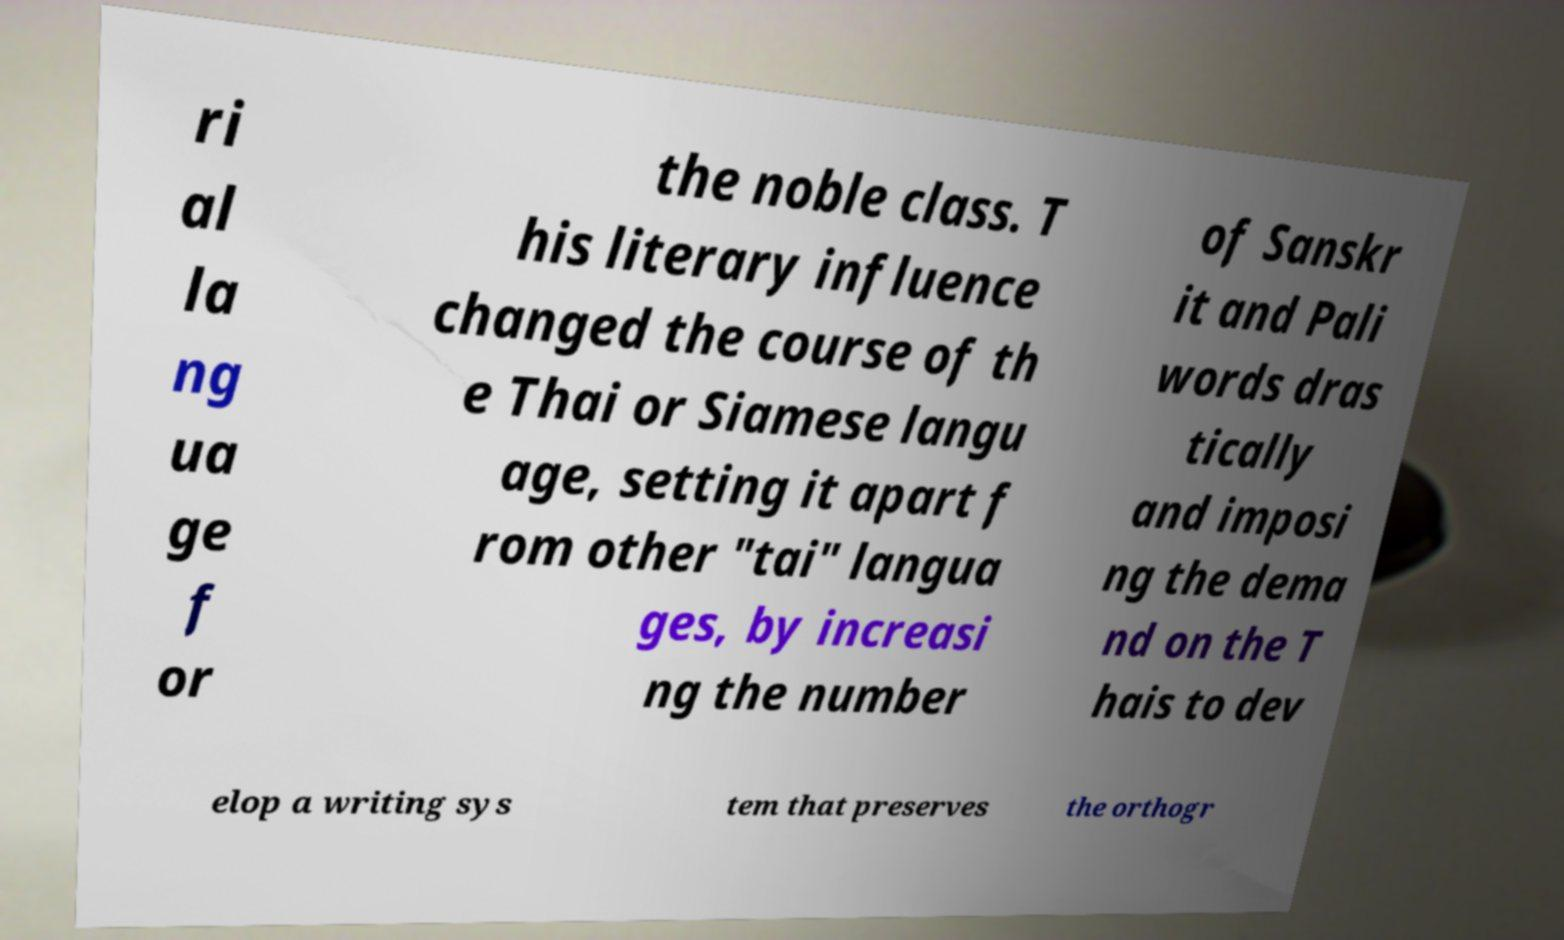Please identify and transcribe the text found in this image. ri al la ng ua ge f or the noble class. T his literary influence changed the course of th e Thai or Siamese langu age, setting it apart f rom other "tai" langua ges, by increasi ng the number of Sanskr it and Pali words dras tically and imposi ng the dema nd on the T hais to dev elop a writing sys tem that preserves the orthogr 